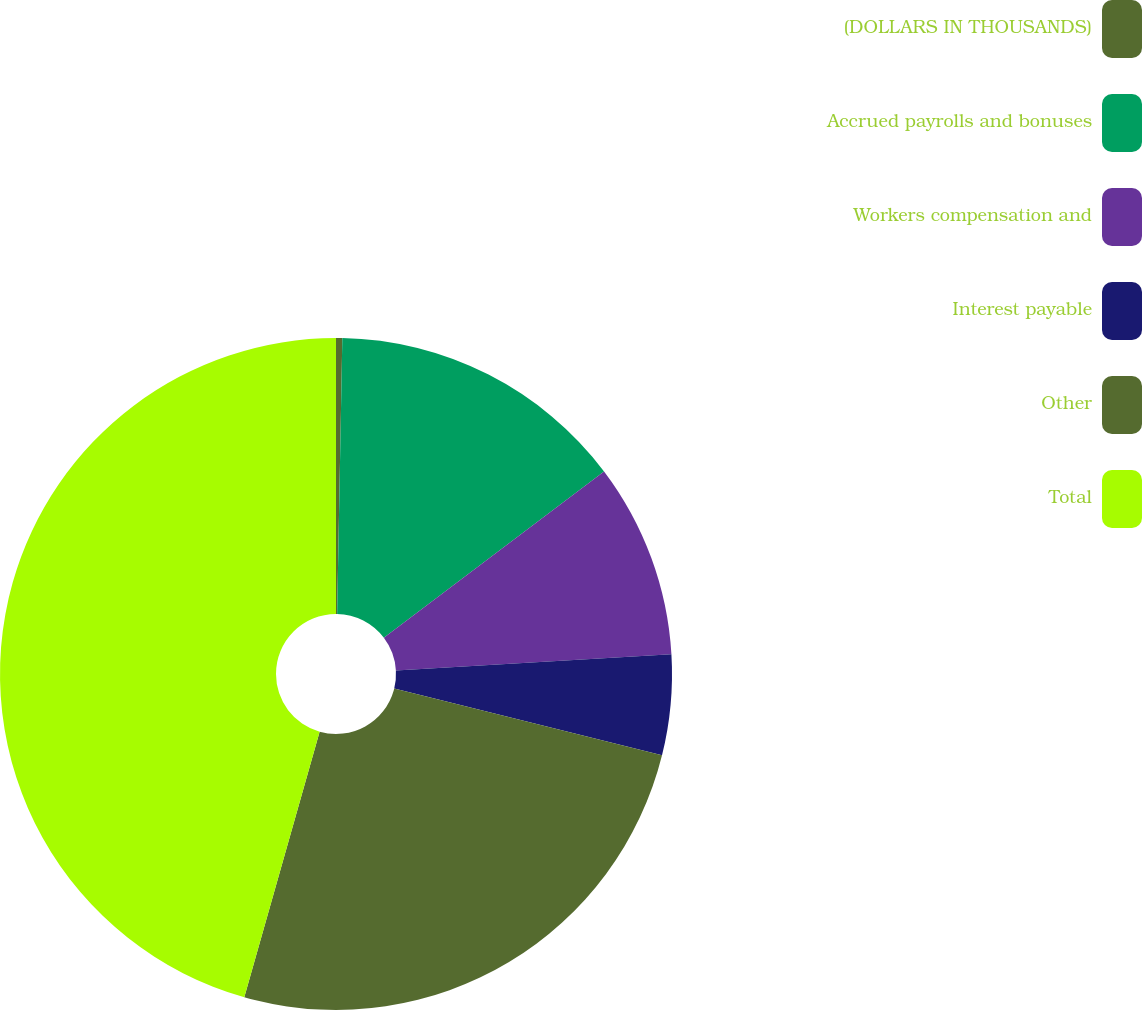Convert chart to OTSL. <chart><loc_0><loc_0><loc_500><loc_500><pie_chart><fcel>(DOLLARS IN THOUSANDS)<fcel>Accrued payrolls and bonuses<fcel>Workers compensation and<fcel>Interest payable<fcel>Other<fcel>Total<nl><fcel>0.3%<fcel>14.4%<fcel>9.36%<fcel>4.83%<fcel>25.51%<fcel>45.6%<nl></chart> 